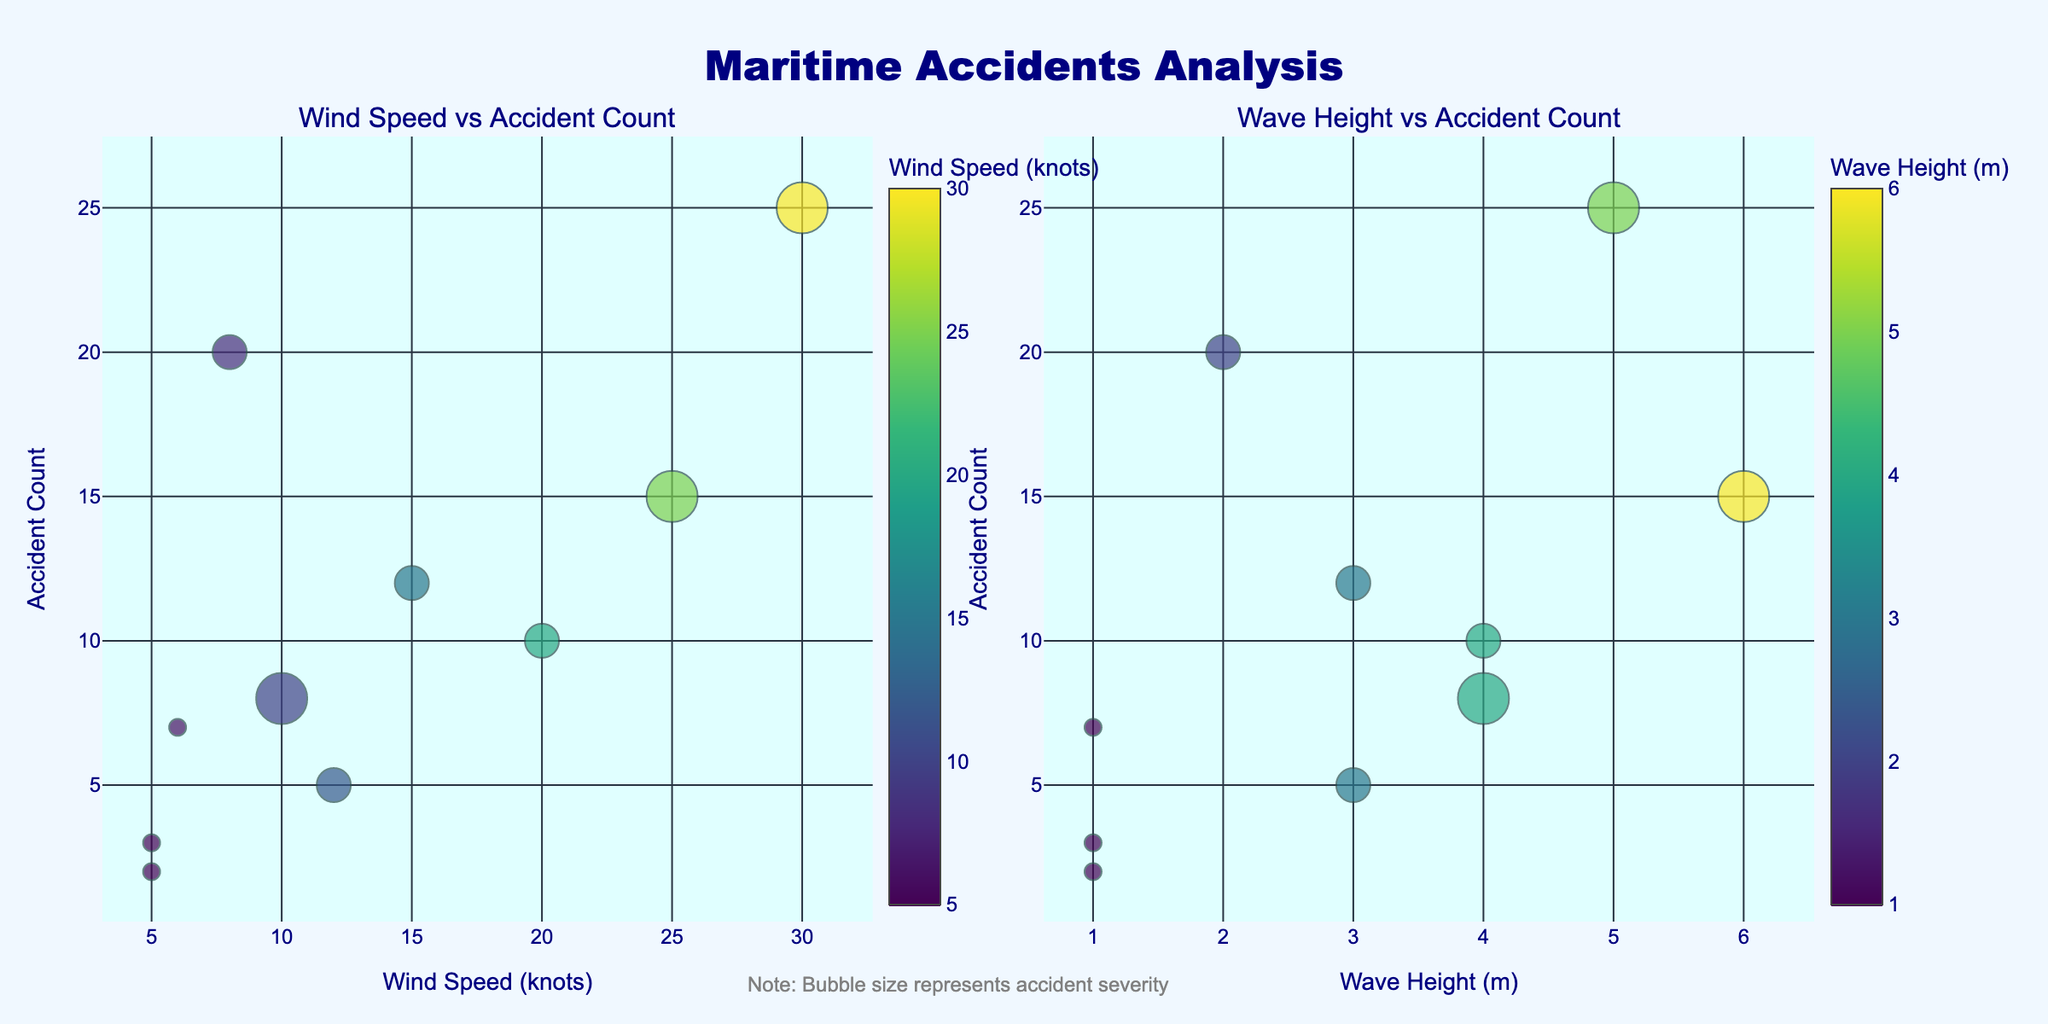How many accidents occurred during clear weather conditions? Refer to the plot, and look for the data points labeled "Clear". There are two data points: Baltic Sea with 3 accidents and Mediterranean Sea with 2 accidents. Summing these up gives 3 + 2 = 5.
Answer: 5 Which weather condition had the highest number of accidents? The highest number of accidents is 25, which corresponds to the data point labeled "Thunderstorm" in the Gulf of Mexico.
Answer: Thunderstorm What's the range of wind speeds shown in the plots? The minimum wind speed is 5 (from clear weather data points), and the maximum is 30 (from the thunderstorm data point). The range is calculated as 30 - 5.
Answer: 25 In which sea did the highest severity of accidents associated with Ice weather occur? From the plot, locate the data point labeled "Ice". The high-severity accident count for Ice weather occurred in the Bering Sea.
Answer: Bering Sea Which bubble plot (Wind Speed vs Accident Count or Wave Height vs Accident Count) shows a clearer trend in accident counts? Inspect both plots visually. The plot of "Wind Speed vs Accident Count" shows a more apparent trend with higher accident counts for higher wind speeds.
Answer: Wind Speed vs Accident Count Compare the accident counts between Fog weather in different locations. There are two data points labeled "Fog": Northern Pacific with 20 accidents and English Channel with 7 accidents.
Answer: Northern Pacific has more accidents than English Channel What is the average wave height for the data points in the Wave Height vs Accident Count plot? Wave heights: 6 (Storm), 2 (Fog), 1 (Clear), 3 (Rain), 4 (Ice), 5 (Thunderstorm), 4 (Heavy Rain), 3 (Snow), 1 (Clear). Sum them up (6+2+1+3+4+5+4+3+1) = 29. Average = 29/9.
Answer: 3.22 Which weather condition had the highest accident count with medium severity? Look for medium severity bubbles in the plot with accident counts. The highest count for medium severity is 20 for Fog in the Northern Pacific.
Answer: Fog Calculate the total number of accidents for High severity weather conditions. High severity weather conditions: Storm (15), Ice (8), Thunderstorm (25). Sum: 15 + 8 + 25.
Answer: 48 Are there more accidents in the Wind Speed vs Accident Count plot above a wind speed of 15 knots or below? Count the data points with wind speeds above and below 15 knots. For above, we have Storm (25), Thunderstorm (30), Heavy Rain (20), providing 3 points. For below, we have 7 data points. Thus, more accidents occur below 15 knots.
Answer: Below 